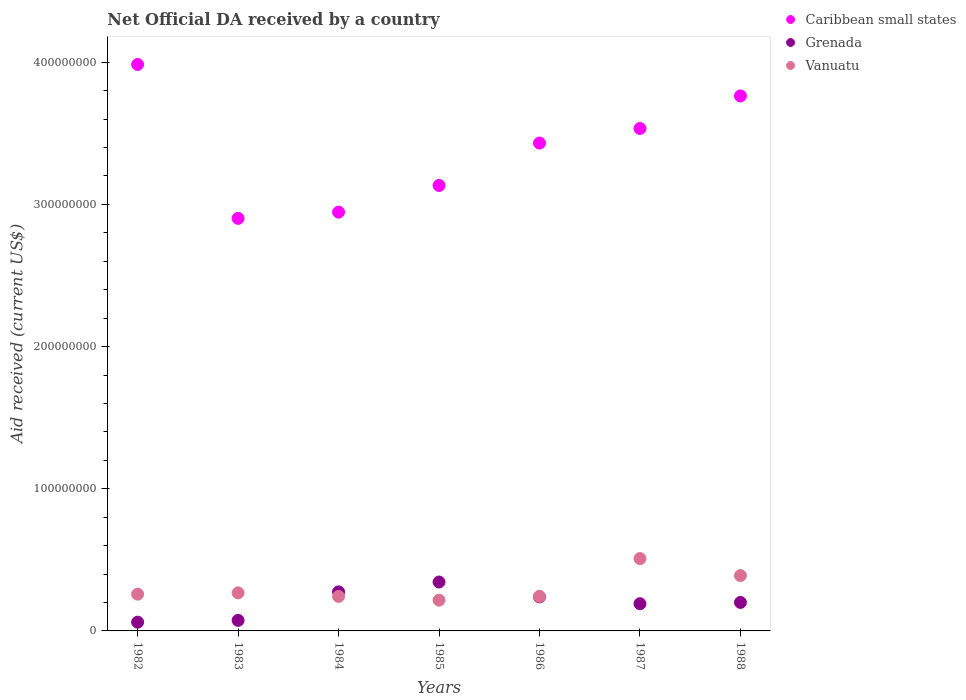How many different coloured dotlines are there?
Make the answer very short. 3. Is the number of dotlines equal to the number of legend labels?
Offer a terse response. Yes. What is the net official development assistance aid received in Grenada in 1984?
Ensure brevity in your answer.  2.75e+07. Across all years, what is the maximum net official development assistance aid received in Grenada?
Your answer should be compact. 3.44e+07. Across all years, what is the minimum net official development assistance aid received in Caribbean small states?
Your response must be concise. 2.90e+08. In which year was the net official development assistance aid received in Grenada maximum?
Make the answer very short. 1985. What is the total net official development assistance aid received in Grenada in the graph?
Keep it short and to the point. 1.39e+08. What is the difference between the net official development assistance aid received in Grenada in 1982 and that in 1984?
Your answer should be very brief. -2.13e+07. What is the difference between the net official development assistance aid received in Grenada in 1983 and the net official development assistance aid received in Vanuatu in 1986?
Your answer should be very brief. -1.68e+07. What is the average net official development assistance aid received in Vanuatu per year?
Offer a terse response. 3.04e+07. In the year 1988, what is the difference between the net official development assistance aid received in Grenada and net official development assistance aid received in Vanuatu?
Your answer should be very brief. -1.89e+07. In how many years, is the net official development assistance aid received in Vanuatu greater than 40000000 US$?
Keep it short and to the point. 1. What is the ratio of the net official development assistance aid received in Vanuatu in 1984 to that in 1987?
Your answer should be very brief. 0.48. Is the difference between the net official development assistance aid received in Grenada in 1982 and 1986 greater than the difference between the net official development assistance aid received in Vanuatu in 1982 and 1986?
Provide a short and direct response. No. What is the difference between the highest and the second highest net official development assistance aid received in Vanuatu?
Offer a terse response. 1.20e+07. What is the difference between the highest and the lowest net official development assistance aid received in Caribbean small states?
Offer a terse response. 1.08e+08. Is the sum of the net official development assistance aid received in Grenada in 1985 and 1987 greater than the maximum net official development assistance aid received in Vanuatu across all years?
Your answer should be compact. Yes. Is it the case that in every year, the sum of the net official development assistance aid received in Caribbean small states and net official development assistance aid received in Vanuatu  is greater than the net official development assistance aid received in Grenada?
Offer a very short reply. Yes. Does the net official development assistance aid received in Grenada monotonically increase over the years?
Your response must be concise. No. Is the net official development assistance aid received in Caribbean small states strictly greater than the net official development assistance aid received in Vanuatu over the years?
Your answer should be compact. Yes. Is the net official development assistance aid received in Grenada strictly less than the net official development assistance aid received in Vanuatu over the years?
Your answer should be very brief. No. How many dotlines are there?
Your answer should be very brief. 3. How many years are there in the graph?
Provide a succinct answer. 7. What is the difference between two consecutive major ticks on the Y-axis?
Offer a very short reply. 1.00e+08. Are the values on the major ticks of Y-axis written in scientific E-notation?
Give a very brief answer. No. Does the graph contain grids?
Ensure brevity in your answer.  No. How many legend labels are there?
Give a very brief answer. 3. What is the title of the graph?
Offer a terse response. Net Official DA received by a country. What is the label or title of the X-axis?
Offer a very short reply. Years. What is the label or title of the Y-axis?
Your answer should be very brief. Aid received (current US$). What is the Aid received (current US$) in Caribbean small states in 1982?
Ensure brevity in your answer.  3.98e+08. What is the Aid received (current US$) in Grenada in 1982?
Your response must be concise. 6.15e+06. What is the Aid received (current US$) in Vanuatu in 1982?
Your answer should be very brief. 2.59e+07. What is the Aid received (current US$) in Caribbean small states in 1983?
Provide a succinct answer. 2.90e+08. What is the Aid received (current US$) in Grenada in 1983?
Offer a very short reply. 7.42e+06. What is the Aid received (current US$) in Vanuatu in 1983?
Keep it short and to the point. 2.68e+07. What is the Aid received (current US$) of Caribbean small states in 1984?
Ensure brevity in your answer.  2.95e+08. What is the Aid received (current US$) of Grenada in 1984?
Provide a short and direct response. 2.75e+07. What is the Aid received (current US$) of Vanuatu in 1984?
Offer a very short reply. 2.43e+07. What is the Aid received (current US$) in Caribbean small states in 1985?
Offer a very short reply. 3.13e+08. What is the Aid received (current US$) of Grenada in 1985?
Give a very brief answer. 3.44e+07. What is the Aid received (current US$) of Vanuatu in 1985?
Your answer should be compact. 2.16e+07. What is the Aid received (current US$) of Caribbean small states in 1986?
Make the answer very short. 3.43e+08. What is the Aid received (current US$) of Grenada in 1986?
Offer a very short reply. 2.39e+07. What is the Aid received (current US$) in Vanuatu in 1986?
Your answer should be compact. 2.43e+07. What is the Aid received (current US$) of Caribbean small states in 1987?
Make the answer very short. 3.53e+08. What is the Aid received (current US$) in Grenada in 1987?
Provide a succinct answer. 1.91e+07. What is the Aid received (current US$) in Vanuatu in 1987?
Your answer should be compact. 5.09e+07. What is the Aid received (current US$) of Caribbean small states in 1988?
Make the answer very short. 3.76e+08. What is the Aid received (current US$) in Grenada in 1988?
Provide a succinct answer. 2.00e+07. What is the Aid received (current US$) of Vanuatu in 1988?
Offer a very short reply. 3.89e+07. Across all years, what is the maximum Aid received (current US$) in Caribbean small states?
Give a very brief answer. 3.98e+08. Across all years, what is the maximum Aid received (current US$) in Grenada?
Provide a succinct answer. 3.44e+07. Across all years, what is the maximum Aid received (current US$) in Vanuatu?
Your answer should be very brief. 5.09e+07. Across all years, what is the minimum Aid received (current US$) in Caribbean small states?
Give a very brief answer. 2.90e+08. Across all years, what is the minimum Aid received (current US$) in Grenada?
Ensure brevity in your answer.  6.15e+06. Across all years, what is the minimum Aid received (current US$) in Vanuatu?
Your answer should be very brief. 2.16e+07. What is the total Aid received (current US$) in Caribbean small states in the graph?
Give a very brief answer. 2.37e+09. What is the total Aid received (current US$) of Grenada in the graph?
Your answer should be compact. 1.39e+08. What is the total Aid received (current US$) in Vanuatu in the graph?
Offer a terse response. 2.13e+08. What is the difference between the Aid received (current US$) of Caribbean small states in 1982 and that in 1983?
Your answer should be compact. 1.08e+08. What is the difference between the Aid received (current US$) in Grenada in 1982 and that in 1983?
Ensure brevity in your answer.  -1.27e+06. What is the difference between the Aid received (current US$) in Vanuatu in 1982 and that in 1983?
Your answer should be very brief. -9.00e+05. What is the difference between the Aid received (current US$) of Caribbean small states in 1982 and that in 1984?
Offer a terse response. 1.04e+08. What is the difference between the Aid received (current US$) of Grenada in 1982 and that in 1984?
Offer a terse response. -2.13e+07. What is the difference between the Aid received (current US$) of Vanuatu in 1982 and that in 1984?
Provide a succinct answer. 1.60e+06. What is the difference between the Aid received (current US$) of Caribbean small states in 1982 and that in 1985?
Ensure brevity in your answer.  8.51e+07. What is the difference between the Aid received (current US$) in Grenada in 1982 and that in 1985?
Make the answer very short. -2.83e+07. What is the difference between the Aid received (current US$) of Vanuatu in 1982 and that in 1985?
Your response must be concise. 4.24e+06. What is the difference between the Aid received (current US$) of Caribbean small states in 1982 and that in 1986?
Keep it short and to the point. 5.53e+07. What is the difference between the Aid received (current US$) in Grenada in 1982 and that in 1986?
Make the answer very short. -1.78e+07. What is the difference between the Aid received (current US$) in Vanuatu in 1982 and that in 1986?
Give a very brief answer. 1.60e+06. What is the difference between the Aid received (current US$) of Caribbean small states in 1982 and that in 1987?
Your answer should be compact. 4.50e+07. What is the difference between the Aid received (current US$) in Grenada in 1982 and that in 1987?
Provide a succinct answer. -1.30e+07. What is the difference between the Aid received (current US$) in Vanuatu in 1982 and that in 1987?
Your answer should be very brief. -2.50e+07. What is the difference between the Aid received (current US$) of Caribbean small states in 1982 and that in 1988?
Keep it short and to the point. 2.21e+07. What is the difference between the Aid received (current US$) of Grenada in 1982 and that in 1988?
Your answer should be compact. -1.39e+07. What is the difference between the Aid received (current US$) in Vanuatu in 1982 and that in 1988?
Offer a terse response. -1.31e+07. What is the difference between the Aid received (current US$) in Caribbean small states in 1983 and that in 1984?
Provide a succinct answer. -4.37e+06. What is the difference between the Aid received (current US$) in Grenada in 1983 and that in 1984?
Keep it short and to the point. -2.00e+07. What is the difference between the Aid received (current US$) in Vanuatu in 1983 and that in 1984?
Offer a terse response. 2.50e+06. What is the difference between the Aid received (current US$) in Caribbean small states in 1983 and that in 1985?
Provide a succinct answer. -2.32e+07. What is the difference between the Aid received (current US$) in Grenada in 1983 and that in 1985?
Give a very brief answer. -2.70e+07. What is the difference between the Aid received (current US$) of Vanuatu in 1983 and that in 1985?
Give a very brief answer. 5.14e+06. What is the difference between the Aid received (current US$) of Caribbean small states in 1983 and that in 1986?
Offer a very short reply. -5.30e+07. What is the difference between the Aid received (current US$) of Grenada in 1983 and that in 1986?
Give a very brief answer. -1.65e+07. What is the difference between the Aid received (current US$) of Vanuatu in 1983 and that in 1986?
Your response must be concise. 2.50e+06. What is the difference between the Aid received (current US$) of Caribbean small states in 1983 and that in 1987?
Provide a succinct answer. -6.32e+07. What is the difference between the Aid received (current US$) of Grenada in 1983 and that in 1987?
Ensure brevity in your answer.  -1.17e+07. What is the difference between the Aid received (current US$) of Vanuatu in 1983 and that in 1987?
Your answer should be compact. -2.41e+07. What is the difference between the Aid received (current US$) of Caribbean small states in 1983 and that in 1988?
Your response must be concise. -8.61e+07. What is the difference between the Aid received (current US$) in Grenada in 1983 and that in 1988?
Keep it short and to the point. -1.26e+07. What is the difference between the Aid received (current US$) of Vanuatu in 1983 and that in 1988?
Provide a short and direct response. -1.22e+07. What is the difference between the Aid received (current US$) of Caribbean small states in 1984 and that in 1985?
Your answer should be very brief. -1.88e+07. What is the difference between the Aid received (current US$) of Grenada in 1984 and that in 1985?
Offer a very short reply. -6.94e+06. What is the difference between the Aid received (current US$) in Vanuatu in 1984 and that in 1985?
Provide a short and direct response. 2.64e+06. What is the difference between the Aid received (current US$) of Caribbean small states in 1984 and that in 1986?
Ensure brevity in your answer.  -4.86e+07. What is the difference between the Aid received (current US$) of Grenada in 1984 and that in 1986?
Provide a succinct answer. 3.53e+06. What is the difference between the Aid received (current US$) in Caribbean small states in 1984 and that in 1987?
Offer a very short reply. -5.88e+07. What is the difference between the Aid received (current US$) in Grenada in 1984 and that in 1987?
Your response must be concise. 8.34e+06. What is the difference between the Aid received (current US$) in Vanuatu in 1984 and that in 1987?
Ensure brevity in your answer.  -2.66e+07. What is the difference between the Aid received (current US$) in Caribbean small states in 1984 and that in 1988?
Keep it short and to the point. -8.18e+07. What is the difference between the Aid received (current US$) in Grenada in 1984 and that in 1988?
Give a very brief answer. 7.44e+06. What is the difference between the Aid received (current US$) in Vanuatu in 1984 and that in 1988?
Provide a succinct answer. -1.47e+07. What is the difference between the Aid received (current US$) in Caribbean small states in 1985 and that in 1986?
Offer a terse response. -2.98e+07. What is the difference between the Aid received (current US$) of Grenada in 1985 and that in 1986?
Keep it short and to the point. 1.05e+07. What is the difference between the Aid received (current US$) of Vanuatu in 1985 and that in 1986?
Keep it short and to the point. -2.64e+06. What is the difference between the Aid received (current US$) of Caribbean small states in 1985 and that in 1987?
Provide a succinct answer. -4.01e+07. What is the difference between the Aid received (current US$) of Grenada in 1985 and that in 1987?
Give a very brief answer. 1.53e+07. What is the difference between the Aid received (current US$) of Vanuatu in 1985 and that in 1987?
Keep it short and to the point. -2.93e+07. What is the difference between the Aid received (current US$) of Caribbean small states in 1985 and that in 1988?
Your answer should be very brief. -6.30e+07. What is the difference between the Aid received (current US$) in Grenada in 1985 and that in 1988?
Give a very brief answer. 1.44e+07. What is the difference between the Aid received (current US$) of Vanuatu in 1985 and that in 1988?
Keep it short and to the point. -1.73e+07. What is the difference between the Aid received (current US$) of Caribbean small states in 1986 and that in 1987?
Your answer should be compact. -1.03e+07. What is the difference between the Aid received (current US$) of Grenada in 1986 and that in 1987?
Offer a very short reply. 4.81e+06. What is the difference between the Aid received (current US$) of Vanuatu in 1986 and that in 1987?
Provide a short and direct response. -2.66e+07. What is the difference between the Aid received (current US$) in Caribbean small states in 1986 and that in 1988?
Offer a terse response. -3.32e+07. What is the difference between the Aid received (current US$) of Grenada in 1986 and that in 1988?
Your answer should be compact. 3.91e+06. What is the difference between the Aid received (current US$) of Vanuatu in 1986 and that in 1988?
Make the answer very short. -1.47e+07. What is the difference between the Aid received (current US$) of Caribbean small states in 1987 and that in 1988?
Provide a succinct answer. -2.29e+07. What is the difference between the Aid received (current US$) of Grenada in 1987 and that in 1988?
Offer a terse response. -9.00e+05. What is the difference between the Aid received (current US$) in Vanuatu in 1987 and that in 1988?
Your answer should be very brief. 1.20e+07. What is the difference between the Aid received (current US$) in Caribbean small states in 1982 and the Aid received (current US$) in Grenada in 1983?
Your answer should be very brief. 3.91e+08. What is the difference between the Aid received (current US$) in Caribbean small states in 1982 and the Aid received (current US$) in Vanuatu in 1983?
Offer a very short reply. 3.72e+08. What is the difference between the Aid received (current US$) of Grenada in 1982 and the Aid received (current US$) of Vanuatu in 1983?
Offer a very short reply. -2.06e+07. What is the difference between the Aid received (current US$) in Caribbean small states in 1982 and the Aid received (current US$) in Grenada in 1984?
Your answer should be very brief. 3.71e+08. What is the difference between the Aid received (current US$) in Caribbean small states in 1982 and the Aid received (current US$) in Vanuatu in 1984?
Provide a succinct answer. 3.74e+08. What is the difference between the Aid received (current US$) of Grenada in 1982 and the Aid received (current US$) of Vanuatu in 1984?
Provide a short and direct response. -1.81e+07. What is the difference between the Aid received (current US$) of Caribbean small states in 1982 and the Aid received (current US$) of Grenada in 1985?
Keep it short and to the point. 3.64e+08. What is the difference between the Aid received (current US$) of Caribbean small states in 1982 and the Aid received (current US$) of Vanuatu in 1985?
Your answer should be very brief. 3.77e+08. What is the difference between the Aid received (current US$) of Grenada in 1982 and the Aid received (current US$) of Vanuatu in 1985?
Make the answer very short. -1.55e+07. What is the difference between the Aid received (current US$) of Caribbean small states in 1982 and the Aid received (current US$) of Grenada in 1986?
Your response must be concise. 3.74e+08. What is the difference between the Aid received (current US$) in Caribbean small states in 1982 and the Aid received (current US$) in Vanuatu in 1986?
Give a very brief answer. 3.74e+08. What is the difference between the Aid received (current US$) in Grenada in 1982 and the Aid received (current US$) in Vanuatu in 1986?
Provide a succinct answer. -1.81e+07. What is the difference between the Aid received (current US$) in Caribbean small states in 1982 and the Aid received (current US$) in Grenada in 1987?
Give a very brief answer. 3.79e+08. What is the difference between the Aid received (current US$) of Caribbean small states in 1982 and the Aid received (current US$) of Vanuatu in 1987?
Provide a succinct answer. 3.48e+08. What is the difference between the Aid received (current US$) in Grenada in 1982 and the Aid received (current US$) in Vanuatu in 1987?
Ensure brevity in your answer.  -4.47e+07. What is the difference between the Aid received (current US$) in Caribbean small states in 1982 and the Aid received (current US$) in Grenada in 1988?
Your answer should be compact. 3.78e+08. What is the difference between the Aid received (current US$) in Caribbean small states in 1982 and the Aid received (current US$) in Vanuatu in 1988?
Provide a short and direct response. 3.60e+08. What is the difference between the Aid received (current US$) in Grenada in 1982 and the Aid received (current US$) in Vanuatu in 1988?
Offer a very short reply. -3.28e+07. What is the difference between the Aid received (current US$) of Caribbean small states in 1983 and the Aid received (current US$) of Grenada in 1984?
Make the answer very short. 2.63e+08. What is the difference between the Aid received (current US$) in Caribbean small states in 1983 and the Aid received (current US$) in Vanuatu in 1984?
Provide a short and direct response. 2.66e+08. What is the difference between the Aid received (current US$) of Grenada in 1983 and the Aid received (current US$) of Vanuatu in 1984?
Offer a terse response. -1.68e+07. What is the difference between the Aid received (current US$) in Caribbean small states in 1983 and the Aid received (current US$) in Grenada in 1985?
Your answer should be very brief. 2.56e+08. What is the difference between the Aid received (current US$) of Caribbean small states in 1983 and the Aid received (current US$) of Vanuatu in 1985?
Your answer should be very brief. 2.69e+08. What is the difference between the Aid received (current US$) of Grenada in 1983 and the Aid received (current US$) of Vanuatu in 1985?
Your response must be concise. -1.42e+07. What is the difference between the Aid received (current US$) in Caribbean small states in 1983 and the Aid received (current US$) in Grenada in 1986?
Give a very brief answer. 2.66e+08. What is the difference between the Aid received (current US$) in Caribbean small states in 1983 and the Aid received (current US$) in Vanuatu in 1986?
Provide a succinct answer. 2.66e+08. What is the difference between the Aid received (current US$) of Grenada in 1983 and the Aid received (current US$) of Vanuatu in 1986?
Your response must be concise. -1.68e+07. What is the difference between the Aid received (current US$) in Caribbean small states in 1983 and the Aid received (current US$) in Grenada in 1987?
Your answer should be compact. 2.71e+08. What is the difference between the Aid received (current US$) in Caribbean small states in 1983 and the Aid received (current US$) in Vanuatu in 1987?
Give a very brief answer. 2.39e+08. What is the difference between the Aid received (current US$) of Grenada in 1983 and the Aid received (current US$) of Vanuatu in 1987?
Ensure brevity in your answer.  -4.35e+07. What is the difference between the Aid received (current US$) of Caribbean small states in 1983 and the Aid received (current US$) of Grenada in 1988?
Offer a terse response. 2.70e+08. What is the difference between the Aid received (current US$) of Caribbean small states in 1983 and the Aid received (current US$) of Vanuatu in 1988?
Offer a terse response. 2.51e+08. What is the difference between the Aid received (current US$) in Grenada in 1983 and the Aid received (current US$) in Vanuatu in 1988?
Give a very brief answer. -3.15e+07. What is the difference between the Aid received (current US$) in Caribbean small states in 1984 and the Aid received (current US$) in Grenada in 1985?
Your answer should be compact. 2.60e+08. What is the difference between the Aid received (current US$) of Caribbean small states in 1984 and the Aid received (current US$) of Vanuatu in 1985?
Keep it short and to the point. 2.73e+08. What is the difference between the Aid received (current US$) of Grenada in 1984 and the Aid received (current US$) of Vanuatu in 1985?
Offer a terse response. 5.84e+06. What is the difference between the Aid received (current US$) in Caribbean small states in 1984 and the Aid received (current US$) in Grenada in 1986?
Your response must be concise. 2.71e+08. What is the difference between the Aid received (current US$) in Caribbean small states in 1984 and the Aid received (current US$) in Vanuatu in 1986?
Provide a short and direct response. 2.70e+08. What is the difference between the Aid received (current US$) in Grenada in 1984 and the Aid received (current US$) in Vanuatu in 1986?
Provide a short and direct response. 3.20e+06. What is the difference between the Aid received (current US$) in Caribbean small states in 1984 and the Aid received (current US$) in Grenada in 1987?
Your answer should be compact. 2.75e+08. What is the difference between the Aid received (current US$) of Caribbean small states in 1984 and the Aid received (current US$) of Vanuatu in 1987?
Your answer should be very brief. 2.44e+08. What is the difference between the Aid received (current US$) of Grenada in 1984 and the Aid received (current US$) of Vanuatu in 1987?
Give a very brief answer. -2.34e+07. What is the difference between the Aid received (current US$) in Caribbean small states in 1984 and the Aid received (current US$) in Grenada in 1988?
Provide a succinct answer. 2.75e+08. What is the difference between the Aid received (current US$) in Caribbean small states in 1984 and the Aid received (current US$) in Vanuatu in 1988?
Give a very brief answer. 2.56e+08. What is the difference between the Aid received (current US$) in Grenada in 1984 and the Aid received (current US$) in Vanuatu in 1988?
Offer a terse response. -1.15e+07. What is the difference between the Aid received (current US$) in Caribbean small states in 1985 and the Aid received (current US$) in Grenada in 1986?
Provide a short and direct response. 2.89e+08. What is the difference between the Aid received (current US$) in Caribbean small states in 1985 and the Aid received (current US$) in Vanuatu in 1986?
Ensure brevity in your answer.  2.89e+08. What is the difference between the Aid received (current US$) in Grenada in 1985 and the Aid received (current US$) in Vanuatu in 1986?
Offer a very short reply. 1.01e+07. What is the difference between the Aid received (current US$) in Caribbean small states in 1985 and the Aid received (current US$) in Grenada in 1987?
Give a very brief answer. 2.94e+08. What is the difference between the Aid received (current US$) of Caribbean small states in 1985 and the Aid received (current US$) of Vanuatu in 1987?
Your answer should be very brief. 2.62e+08. What is the difference between the Aid received (current US$) in Grenada in 1985 and the Aid received (current US$) in Vanuatu in 1987?
Ensure brevity in your answer.  -1.65e+07. What is the difference between the Aid received (current US$) in Caribbean small states in 1985 and the Aid received (current US$) in Grenada in 1988?
Give a very brief answer. 2.93e+08. What is the difference between the Aid received (current US$) of Caribbean small states in 1985 and the Aid received (current US$) of Vanuatu in 1988?
Your answer should be compact. 2.74e+08. What is the difference between the Aid received (current US$) in Grenada in 1985 and the Aid received (current US$) in Vanuatu in 1988?
Keep it short and to the point. -4.52e+06. What is the difference between the Aid received (current US$) in Caribbean small states in 1986 and the Aid received (current US$) in Grenada in 1987?
Provide a short and direct response. 3.24e+08. What is the difference between the Aid received (current US$) in Caribbean small states in 1986 and the Aid received (current US$) in Vanuatu in 1987?
Offer a very short reply. 2.92e+08. What is the difference between the Aid received (current US$) in Grenada in 1986 and the Aid received (current US$) in Vanuatu in 1987?
Offer a very short reply. -2.70e+07. What is the difference between the Aid received (current US$) in Caribbean small states in 1986 and the Aid received (current US$) in Grenada in 1988?
Provide a short and direct response. 3.23e+08. What is the difference between the Aid received (current US$) of Caribbean small states in 1986 and the Aid received (current US$) of Vanuatu in 1988?
Ensure brevity in your answer.  3.04e+08. What is the difference between the Aid received (current US$) of Grenada in 1986 and the Aid received (current US$) of Vanuatu in 1988?
Offer a very short reply. -1.50e+07. What is the difference between the Aid received (current US$) in Caribbean small states in 1987 and the Aid received (current US$) in Grenada in 1988?
Your response must be concise. 3.33e+08. What is the difference between the Aid received (current US$) of Caribbean small states in 1987 and the Aid received (current US$) of Vanuatu in 1988?
Your answer should be very brief. 3.14e+08. What is the difference between the Aid received (current US$) of Grenada in 1987 and the Aid received (current US$) of Vanuatu in 1988?
Offer a terse response. -1.98e+07. What is the average Aid received (current US$) of Caribbean small states per year?
Provide a short and direct response. 3.38e+08. What is the average Aid received (current US$) in Grenada per year?
Offer a terse response. 1.98e+07. What is the average Aid received (current US$) in Vanuatu per year?
Ensure brevity in your answer.  3.04e+07. In the year 1982, what is the difference between the Aid received (current US$) of Caribbean small states and Aid received (current US$) of Grenada?
Your answer should be very brief. 3.92e+08. In the year 1982, what is the difference between the Aid received (current US$) of Caribbean small states and Aid received (current US$) of Vanuatu?
Offer a terse response. 3.73e+08. In the year 1982, what is the difference between the Aid received (current US$) of Grenada and Aid received (current US$) of Vanuatu?
Provide a succinct answer. -1.97e+07. In the year 1983, what is the difference between the Aid received (current US$) of Caribbean small states and Aid received (current US$) of Grenada?
Your answer should be very brief. 2.83e+08. In the year 1983, what is the difference between the Aid received (current US$) of Caribbean small states and Aid received (current US$) of Vanuatu?
Give a very brief answer. 2.63e+08. In the year 1983, what is the difference between the Aid received (current US$) in Grenada and Aid received (current US$) in Vanuatu?
Provide a short and direct response. -1.94e+07. In the year 1984, what is the difference between the Aid received (current US$) in Caribbean small states and Aid received (current US$) in Grenada?
Your answer should be compact. 2.67e+08. In the year 1984, what is the difference between the Aid received (current US$) in Caribbean small states and Aid received (current US$) in Vanuatu?
Ensure brevity in your answer.  2.70e+08. In the year 1984, what is the difference between the Aid received (current US$) of Grenada and Aid received (current US$) of Vanuatu?
Your answer should be very brief. 3.20e+06. In the year 1985, what is the difference between the Aid received (current US$) of Caribbean small states and Aid received (current US$) of Grenada?
Your answer should be very brief. 2.79e+08. In the year 1985, what is the difference between the Aid received (current US$) of Caribbean small states and Aid received (current US$) of Vanuatu?
Your answer should be compact. 2.92e+08. In the year 1985, what is the difference between the Aid received (current US$) in Grenada and Aid received (current US$) in Vanuatu?
Your response must be concise. 1.28e+07. In the year 1986, what is the difference between the Aid received (current US$) of Caribbean small states and Aid received (current US$) of Grenada?
Your answer should be very brief. 3.19e+08. In the year 1986, what is the difference between the Aid received (current US$) of Caribbean small states and Aid received (current US$) of Vanuatu?
Provide a succinct answer. 3.19e+08. In the year 1986, what is the difference between the Aid received (current US$) in Grenada and Aid received (current US$) in Vanuatu?
Your response must be concise. -3.30e+05. In the year 1987, what is the difference between the Aid received (current US$) in Caribbean small states and Aid received (current US$) in Grenada?
Ensure brevity in your answer.  3.34e+08. In the year 1987, what is the difference between the Aid received (current US$) in Caribbean small states and Aid received (current US$) in Vanuatu?
Keep it short and to the point. 3.03e+08. In the year 1987, what is the difference between the Aid received (current US$) of Grenada and Aid received (current US$) of Vanuatu?
Keep it short and to the point. -3.18e+07. In the year 1988, what is the difference between the Aid received (current US$) in Caribbean small states and Aid received (current US$) in Grenada?
Offer a very short reply. 3.56e+08. In the year 1988, what is the difference between the Aid received (current US$) of Caribbean small states and Aid received (current US$) of Vanuatu?
Ensure brevity in your answer.  3.37e+08. In the year 1988, what is the difference between the Aid received (current US$) of Grenada and Aid received (current US$) of Vanuatu?
Your answer should be compact. -1.89e+07. What is the ratio of the Aid received (current US$) in Caribbean small states in 1982 to that in 1983?
Your answer should be very brief. 1.37. What is the ratio of the Aid received (current US$) of Grenada in 1982 to that in 1983?
Offer a very short reply. 0.83. What is the ratio of the Aid received (current US$) of Vanuatu in 1982 to that in 1983?
Ensure brevity in your answer.  0.97. What is the ratio of the Aid received (current US$) in Caribbean small states in 1982 to that in 1984?
Offer a terse response. 1.35. What is the ratio of the Aid received (current US$) in Grenada in 1982 to that in 1984?
Give a very brief answer. 0.22. What is the ratio of the Aid received (current US$) of Vanuatu in 1982 to that in 1984?
Ensure brevity in your answer.  1.07. What is the ratio of the Aid received (current US$) of Caribbean small states in 1982 to that in 1985?
Your answer should be compact. 1.27. What is the ratio of the Aid received (current US$) in Grenada in 1982 to that in 1985?
Provide a succinct answer. 0.18. What is the ratio of the Aid received (current US$) of Vanuatu in 1982 to that in 1985?
Your response must be concise. 1.2. What is the ratio of the Aid received (current US$) of Caribbean small states in 1982 to that in 1986?
Make the answer very short. 1.16. What is the ratio of the Aid received (current US$) in Grenada in 1982 to that in 1986?
Your response must be concise. 0.26. What is the ratio of the Aid received (current US$) of Vanuatu in 1982 to that in 1986?
Your response must be concise. 1.07. What is the ratio of the Aid received (current US$) in Caribbean small states in 1982 to that in 1987?
Your answer should be compact. 1.13. What is the ratio of the Aid received (current US$) in Grenada in 1982 to that in 1987?
Provide a short and direct response. 0.32. What is the ratio of the Aid received (current US$) of Vanuatu in 1982 to that in 1987?
Make the answer very short. 0.51. What is the ratio of the Aid received (current US$) of Caribbean small states in 1982 to that in 1988?
Make the answer very short. 1.06. What is the ratio of the Aid received (current US$) in Grenada in 1982 to that in 1988?
Provide a short and direct response. 0.31. What is the ratio of the Aid received (current US$) of Vanuatu in 1982 to that in 1988?
Give a very brief answer. 0.66. What is the ratio of the Aid received (current US$) of Caribbean small states in 1983 to that in 1984?
Provide a short and direct response. 0.99. What is the ratio of the Aid received (current US$) in Grenada in 1983 to that in 1984?
Offer a very short reply. 0.27. What is the ratio of the Aid received (current US$) of Vanuatu in 1983 to that in 1984?
Provide a succinct answer. 1.1. What is the ratio of the Aid received (current US$) in Caribbean small states in 1983 to that in 1985?
Offer a terse response. 0.93. What is the ratio of the Aid received (current US$) in Grenada in 1983 to that in 1985?
Your response must be concise. 0.22. What is the ratio of the Aid received (current US$) in Vanuatu in 1983 to that in 1985?
Give a very brief answer. 1.24. What is the ratio of the Aid received (current US$) in Caribbean small states in 1983 to that in 1986?
Your answer should be compact. 0.85. What is the ratio of the Aid received (current US$) of Grenada in 1983 to that in 1986?
Provide a short and direct response. 0.31. What is the ratio of the Aid received (current US$) of Vanuatu in 1983 to that in 1986?
Ensure brevity in your answer.  1.1. What is the ratio of the Aid received (current US$) of Caribbean small states in 1983 to that in 1987?
Your answer should be very brief. 0.82. What is the ratio of the Aid received (current US$) in Grenada in 1983 to that in 1987?
Keep it short and to the point. 0.39. What is the ratio of the Aid received (current US$) of Vanuatu in 1983 to that in 1987?
Provide a short and direct response. 0.53. What is the ratio of the Aid received (current US$) in Caribbean small states in 1983 to that in 1988?
Offer a very short reply. 0.77. What is the ratio of the Aid received (current US$) of Grenada in 1983 to that in 1988?
Your answer should be very brief. 0.37. What is the ratio of the Aid received (current US$) of Vanuatu in 1983 to that in 1988?
Provide a short and direct response. 0.69. What is the ratio of the Aid received (current US$) of Caribbean small states in 1984 to that in 1985?
Offer a very short reply. 0.94. What is the ratio of the Aid received (current US$) of Grenada in 1984 to that in 1985?
Provide a short and direct response. 0.8. What is the ratio of the Aid received (current US$) in Vanuatu in 1984 to that in 1985?
Give a very brief answer. 1.12. What is the ratio of the Aid received (current US$) in Caribbean small states in 1984 to that in 1986?
Your answer should be very brief. 0.86. What is the ratio of the Aid received (current US$) in Grenada in 1984 to that in 1986?
Your response must be concise. 1.15. What is the ratio of the Aid received (current US$) in Vanuatu in 1984 to that in 1986?
Make the answer very short. 1. What is the ratio of the Aid received (current US$) of Caribbean small states in 1984 to that in 1987?
Keep it short and to the point. 0.83. What is the ratio of the Aid received (current US$) of Grenada in 1984 to that in 1987?
Offer a very short reply. 1.44. What is the ratio of the Aid received (current US$) in Vanuatu in 1984 to that in 1987?
Give a very brief answer. 0.48. What is the ratio of the Aid received (current US$) of Caribbean small states in 1984 to that in 1988?
Provide a short and direct response. 0.78. What is the ratio of the Aid received (current US$) of Grenada in 1984 to that in 1988?
Provide a succinct answer. 1.37. What is the ratio of the Aid received (current US$) of Vanuatu in 1984 to that in 1988?
Offer a terse response. 0.62. What is the ratio of the Aid received (current US$) of Caribbean small states in 1985 to that in 1986?
Make the answer very short. 0.91. What is the ratio of the Aid received (current US$) in Grenada in 1985 to that in 1986?
Make the answer very short. 1.44. What is the ratio of the Aid received (current US$) in Vanuatu in 1985 to that in 1986?
Provide a short and direct response. 0.89. What is the ratio of the Aid received (current US$) of Caribbean small states in 1985 to that in 1987?
Offer a terse response. 0.89. What is the ratio of the Aid received (current US$) in Grenada in 1985 to that in 1987?
Provide a succinct answer. 1.8. What is the ratio of the Aid received (current US$) in Vanuatu in 1985 to that in 1987?
Offer a terse response. 0.42. What is the ratio of the Aid received (current US$) of Caribbean small states in 1985 to that in 1988?
Make the answer very short. 0.83. What is the ratio of the Aid received (current US$) of Grenada in 1985 to that in 1988?
Your answer should be compact. 1.72. What is the ratio of the Aid received (current US$) in Vanuatu in 1985 to that in 1988?
Your response must be concise. 0.56. What is the ratio of the Aid received (current US$) of Grenada in 1986 to that in 1987?
Give a very brief answer. 1.25. What is the ratio of the Aid received (current US$) of Vanuatu in 1986 to that in 1987?
Ensure brevity in your answer.  0.48. What is the ratio of the Aid received (current US$) in Caribbean small states in 1986 to that in 1988?
Provide a short and direct response. 0.91. What is the ratio of the Aid received (current US$) of Grenada in 1986 to that in 1988?
Keep it short and to the point. 1.2. What is the ratio of the Aid received (current US$) in Vanuatu in 1986 to that in 1988?
Your response must be concise. 0.62. What is the ratio of the Aid received (current US$) of Caribbean small states in 1987 to that in 1988?
Your answer should be compact. 0.94. What is the ratio of the Aid received (current US$) of Grenada in 1987 to that in 1988?
Your answer should be very brief. 0.96. What is the ratio of the Aid received (current US$) in Vanuatu in 1987 to that in 1988?
Offer a terse response. 1.31. What is the difference between the highest and the second highest Aid received (current US$) of Caribbean small states?
Make the answer very short. 2.21e+07. What is the difference between the highest and the second highest Aid received (current US$) in Grenada?
Keep it short and to the point. 6.94e+06. What is the difference between the highest and the second highest Aid received (current US$) of Vanuatu?
Your response must be concise. 1.20e+07. What is the difference between the highest and the lowest Aid received (current US$) of Caribbean small states?
Offer a very short reply. 1.08e+08. What is the difference between the highest and the lowest Aid received (current US$) of Grenada?
Make the answer very short. 2.83e+07. What is the difference between the highest and the lowest Aid received (current US$) of Vanuatu?
Provide a succinct answer. 2.93e+07. 